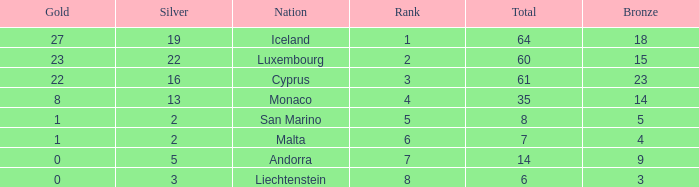Where does Iceland rank with under 19 silvers? None. Parse the table in full. {'header': ['Gold', 'Silver', 'Nation', 'Rank', 'Total', 'Bronze'], 'rows': [['27', '19', 'Iceland', '1', '64', '18'], ['23', '22', 'Luxembourg', '2', '60', '15'], ['22', '16', 'Cyprus', '3', '61', '23'], ['8', '13', 'Monaco', '4', '35', '14'], ['1', '2', 'San Marino', '5', '8', '5'], ['1', '2', 'Malta', '6', '7', '4'], ['0', '5', 'Andorra', '7', '14', '9'], ['0', '3', 'Liechtenstein', '8', '6', '3']]} 